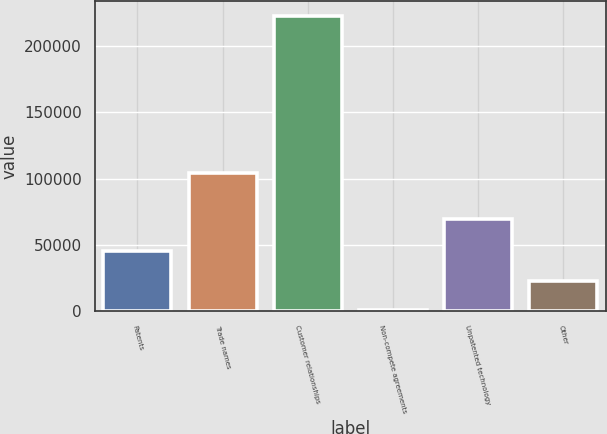Convert chart. <chart><loc_0><loc_0><loc_500><loc_500><bar_chart><fcel>Patents<fcel>Trade names<fcel>Customer relationships<fcel>Non-compete agreements<fcel>Unpatented technology<fcel>Other<nl><fcel>45169.2<fcel>104118<fcel>222486<fcel>840<fcel>69760<fcel>23004.6<nl></chart> 